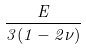<formula> <loc_0><loc_0><loc_500><loc_500>\frac { E } { 3 ( 1 - 2 \nu ) }</formula> 